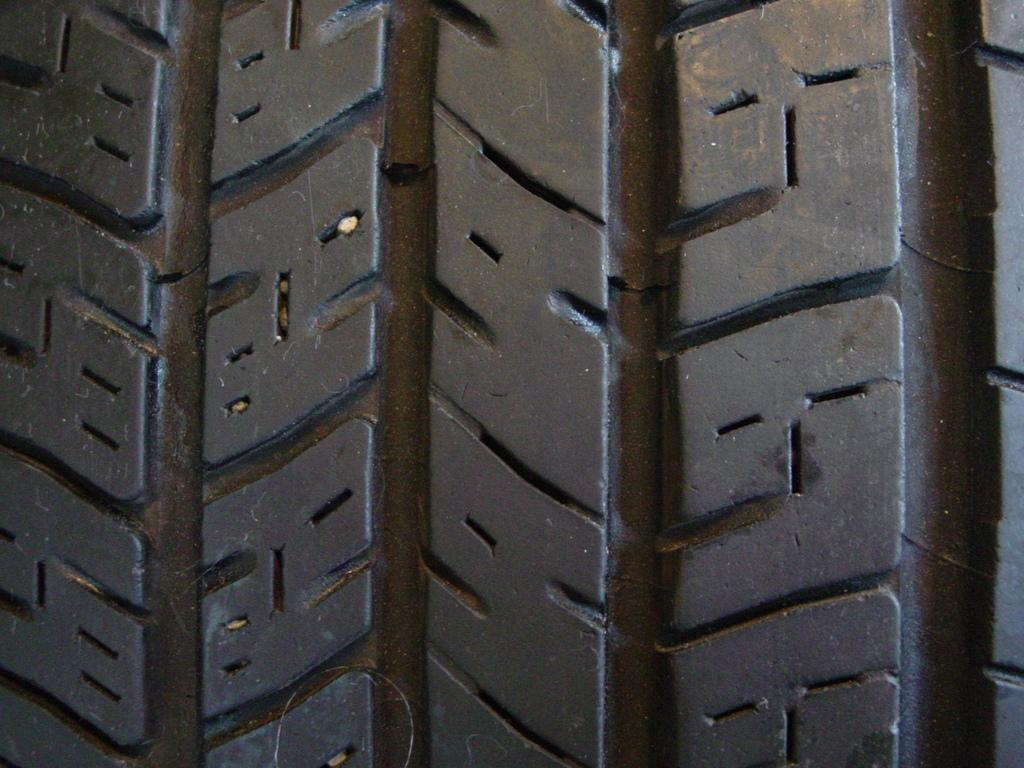What is the color of the main object in the image? The main object in the image is black. Can you describe the design or pattern of the object? Unfortunately, the provided facts do not mention any specific design or pattern on the object. How many pigs are playing with the toy in the image? There is no toy or pigs present in the image; it features a black designed object. 